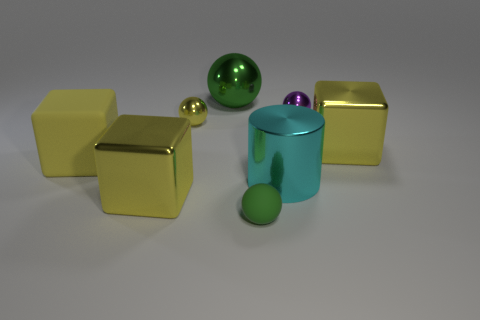What could be the function of these objects if they were real? If these objects were real, they could serve decorative purposes due to their shiny and sleek appearance, possibly as modern art pieces or as part of a designer's collection for aesthetic enhancement in an interior space. 